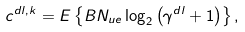Convert formula to latex. <formula><loc_0><loc_0><loc_500><loc_500>c ^ { d l , k } = E \left \{ B N _ { u e } \log _ { 2 } \left ( \gamma ^ { d l } + 1 \right ) \right \} ,</formula> 